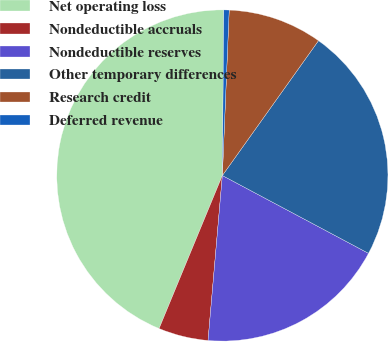<chart> <loc_0><loc_0><loc_500><loc_500><pie_chart><fcel>Net operating loss<fcel>Nondeductible accruals<fcel>Nondeductible reserves<fcel>Other temporary differences<fcel>Research credit<fcel>Deferred revenue<nl><fcel>43.9%<fcel>4.86%<fcel>18.59%<fcel>22.93%<fcel>9.2%<fcel>0.52%<nl></chart> 